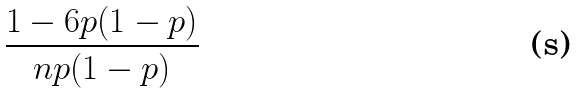<formula> <loc_0><loc_0><loc_500><loc_500>\frac { 1 - 6 p ( 1 - p ) } { n p ( 1 - p ) }</formula> 